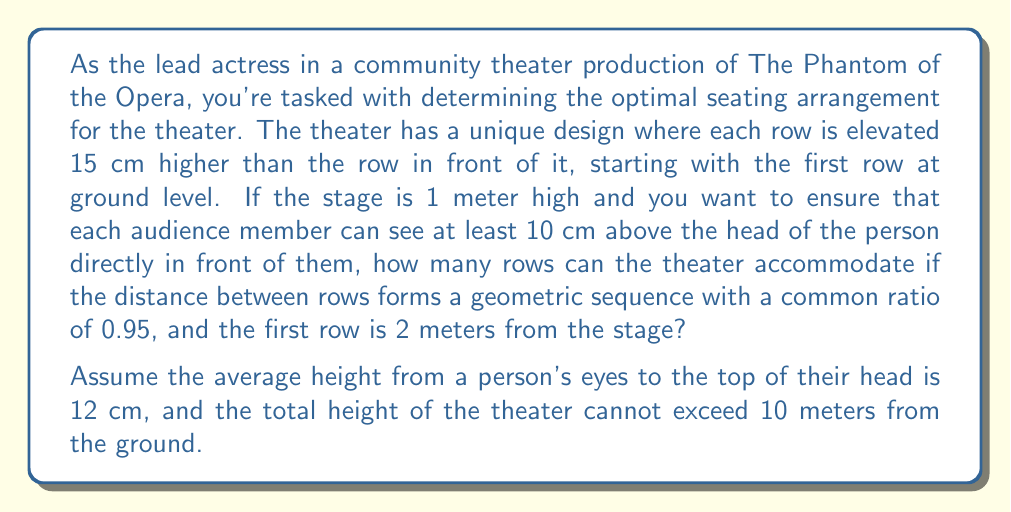What is the answer to this math problem? Let's approach this step-by-step:

1) First, let's define our geometric sequence. The distance between rows forms a geometric sequence with:
   $a_1 = 2$ (first term, distance of first row from stage)
   $r = 0.95$ (common ratio)

2) The general term of this sequence is given by:
   $a_n = a_1 \cdot r^{n-1} = 2 \cdot 0.95^{n-1}$

3) Now, let's consider the height requirements. For the $n$th row:
   - Height of stage: 1 m
   - Total elevation of rows: $0.15(n-1)$ m
   - Minimum visible height above previous row: 0.10 m
   - Height difference between eyes and top of head: 0.12 m

4) For the $n$th row to see properly, we need:

   $$ 1 + 0.15(n-1) - (1 + 0.15(n-2)) \geq 0.10 + 0.12 $$

   Simplifying:
   $$ 0.15 \geq 0.22 $$

   This is always true, so every row will be able to see properly.

5) Now, we need to find the maximum number of rows that fit within 10 meters height:

   $$ 1 + 0.15(n-1) \leq 10 $$

   Solving for $n$:
   $$ n \leq 61 $$

6) Finally, we need to check the total distance to the last row:

   $$ S_n = \frac{a_1(1-r^n)}{1-r} = \frac{2(1-0.95^n)}{1-0.95} = 40(1-0.95^n) $$

7) We want the largest $n$ where $S_n \leq 40$ (since the theater is 10m high and 4 times as long):

   $$ 40(1-0.95^n) \leq 40 $$
   $$ 1-0.95^n \leq 1 $$
   $$ -0.95^n \leq 0 $$

   This is always true, so this doesn't limit our number of rows.

Therefore, the maximum number of rows is 61.
Answer: The theater can accommodate 61 rows. 